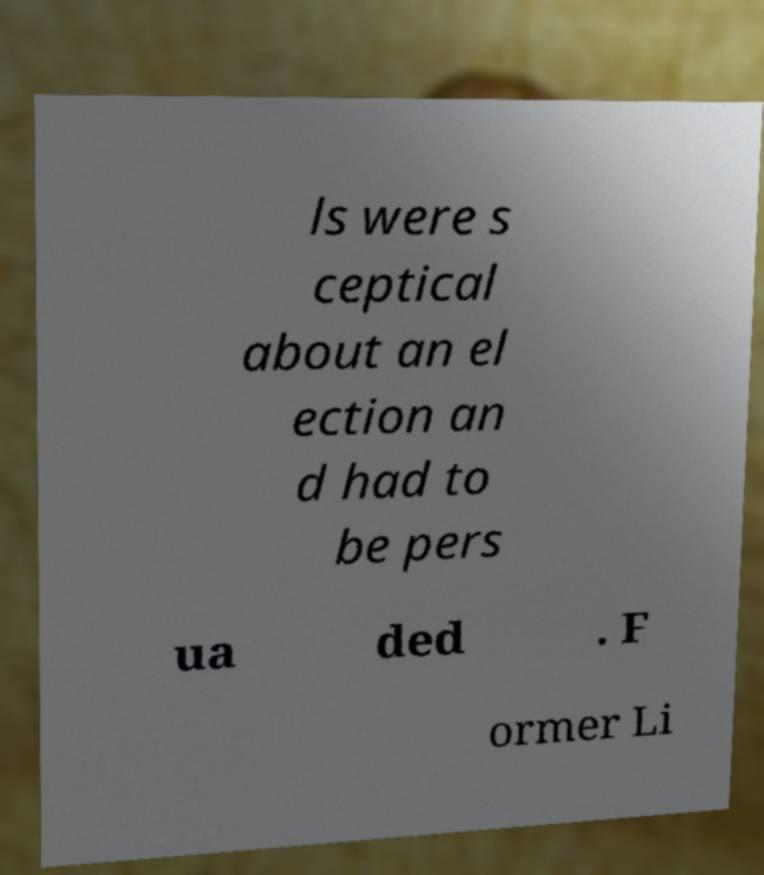Can you accurately transcribe the text from the provided image for me? ls were s ceptical about an el ection an d had to be pers ua ded . F ormer Li 